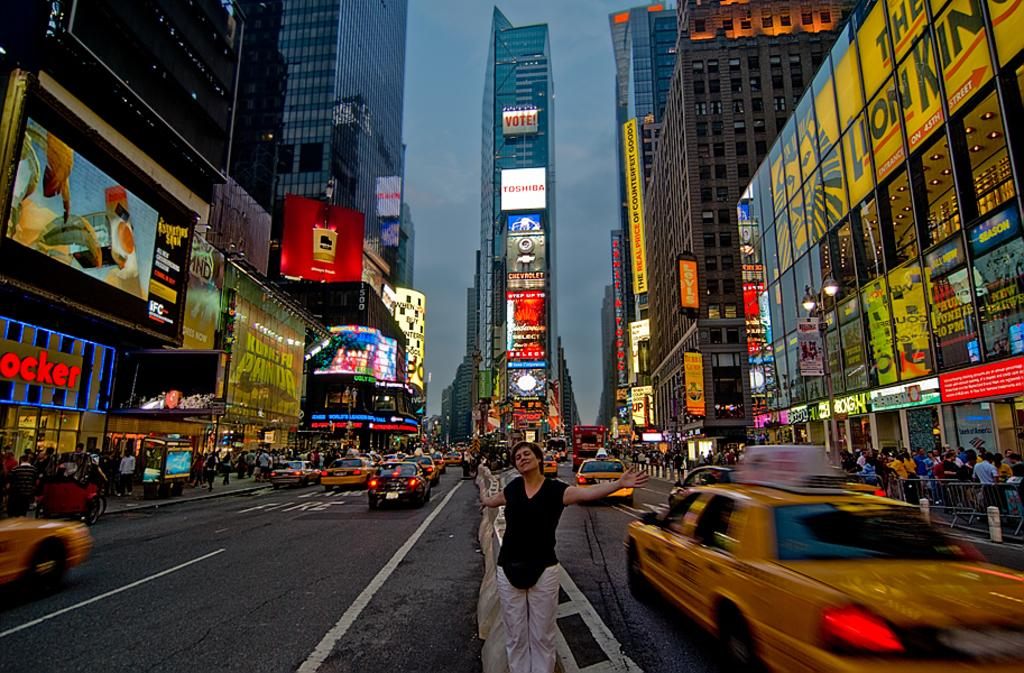<image>
Provide a brief description of the given image. A woman is standing in the center of a city street with rows of stores like footlocker and signs on a tall building with an advertisement for Toshiba. 